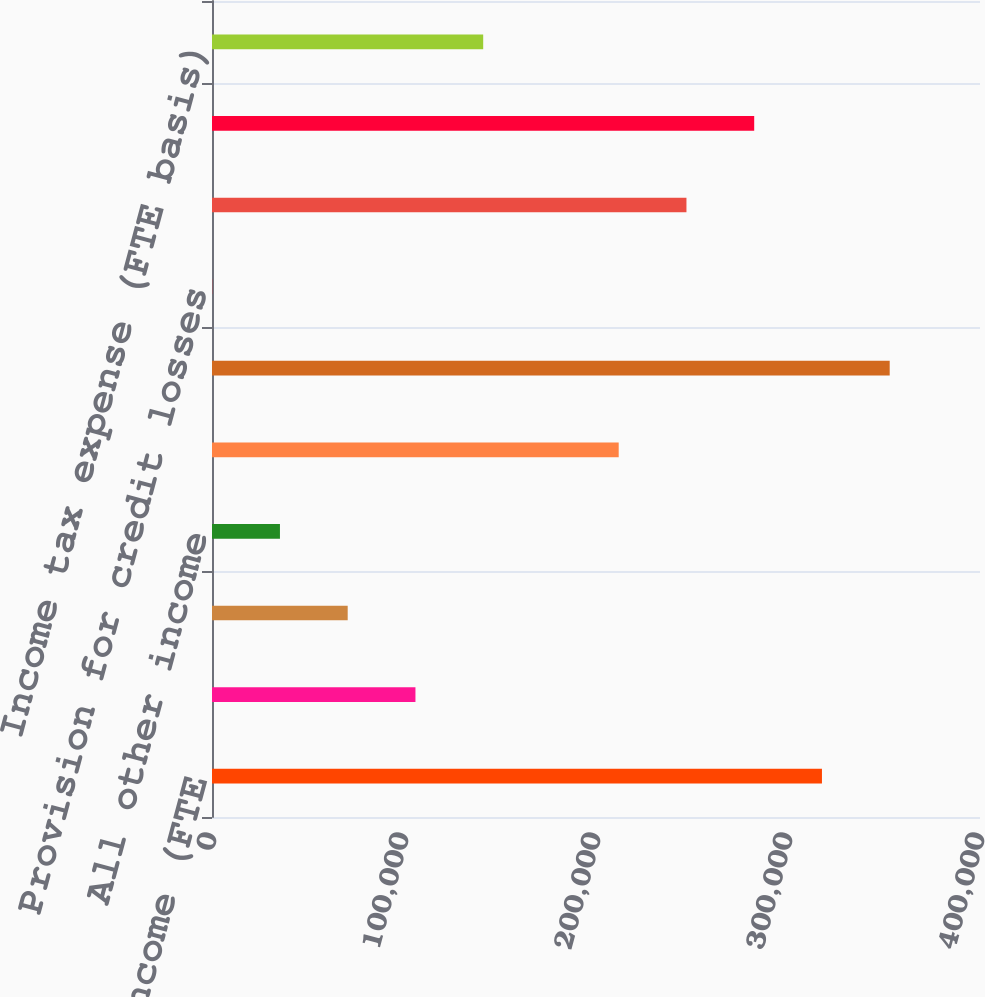Convert chart to OTSL. <chart><loc_0><loc_0><loc_500><loc_500><bar_chart><fcel>Net interest income (FTE<fcel>Service charges<fcel>Investment banking fees<fcel>All other income<fcel>Total noninterest income<fcel>Total revenue net of interest<fcel>Provision for credit losses<fcel>Noninterest expense<fcel>Income before income taxes<fcel>Income tax expense (FTE basis)<nl><fcel>317682<fcel>105963<fcel>70676.2<fcel>35389.6<fcel>211823<fcel>352969<fcel>103<fcel>247109<fcel>282396<fcel>141249<nl></chart> 